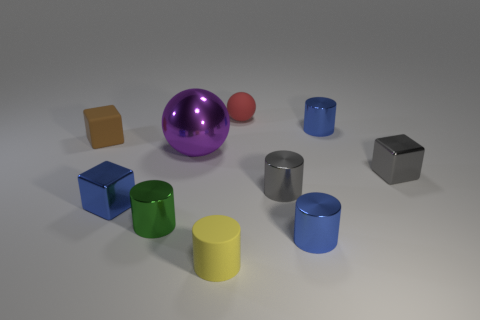Describe the textures of the different materials shown. In the image, we observe a contrasting array of textures: the yellow and green cylinders have a matte texture, which diffuses the light softly; in contrast, the purple sphere, the red sphere, and the blue cylinder exhibit a glossy finish that reflects light, creating bright highlights and sharp reflections. 